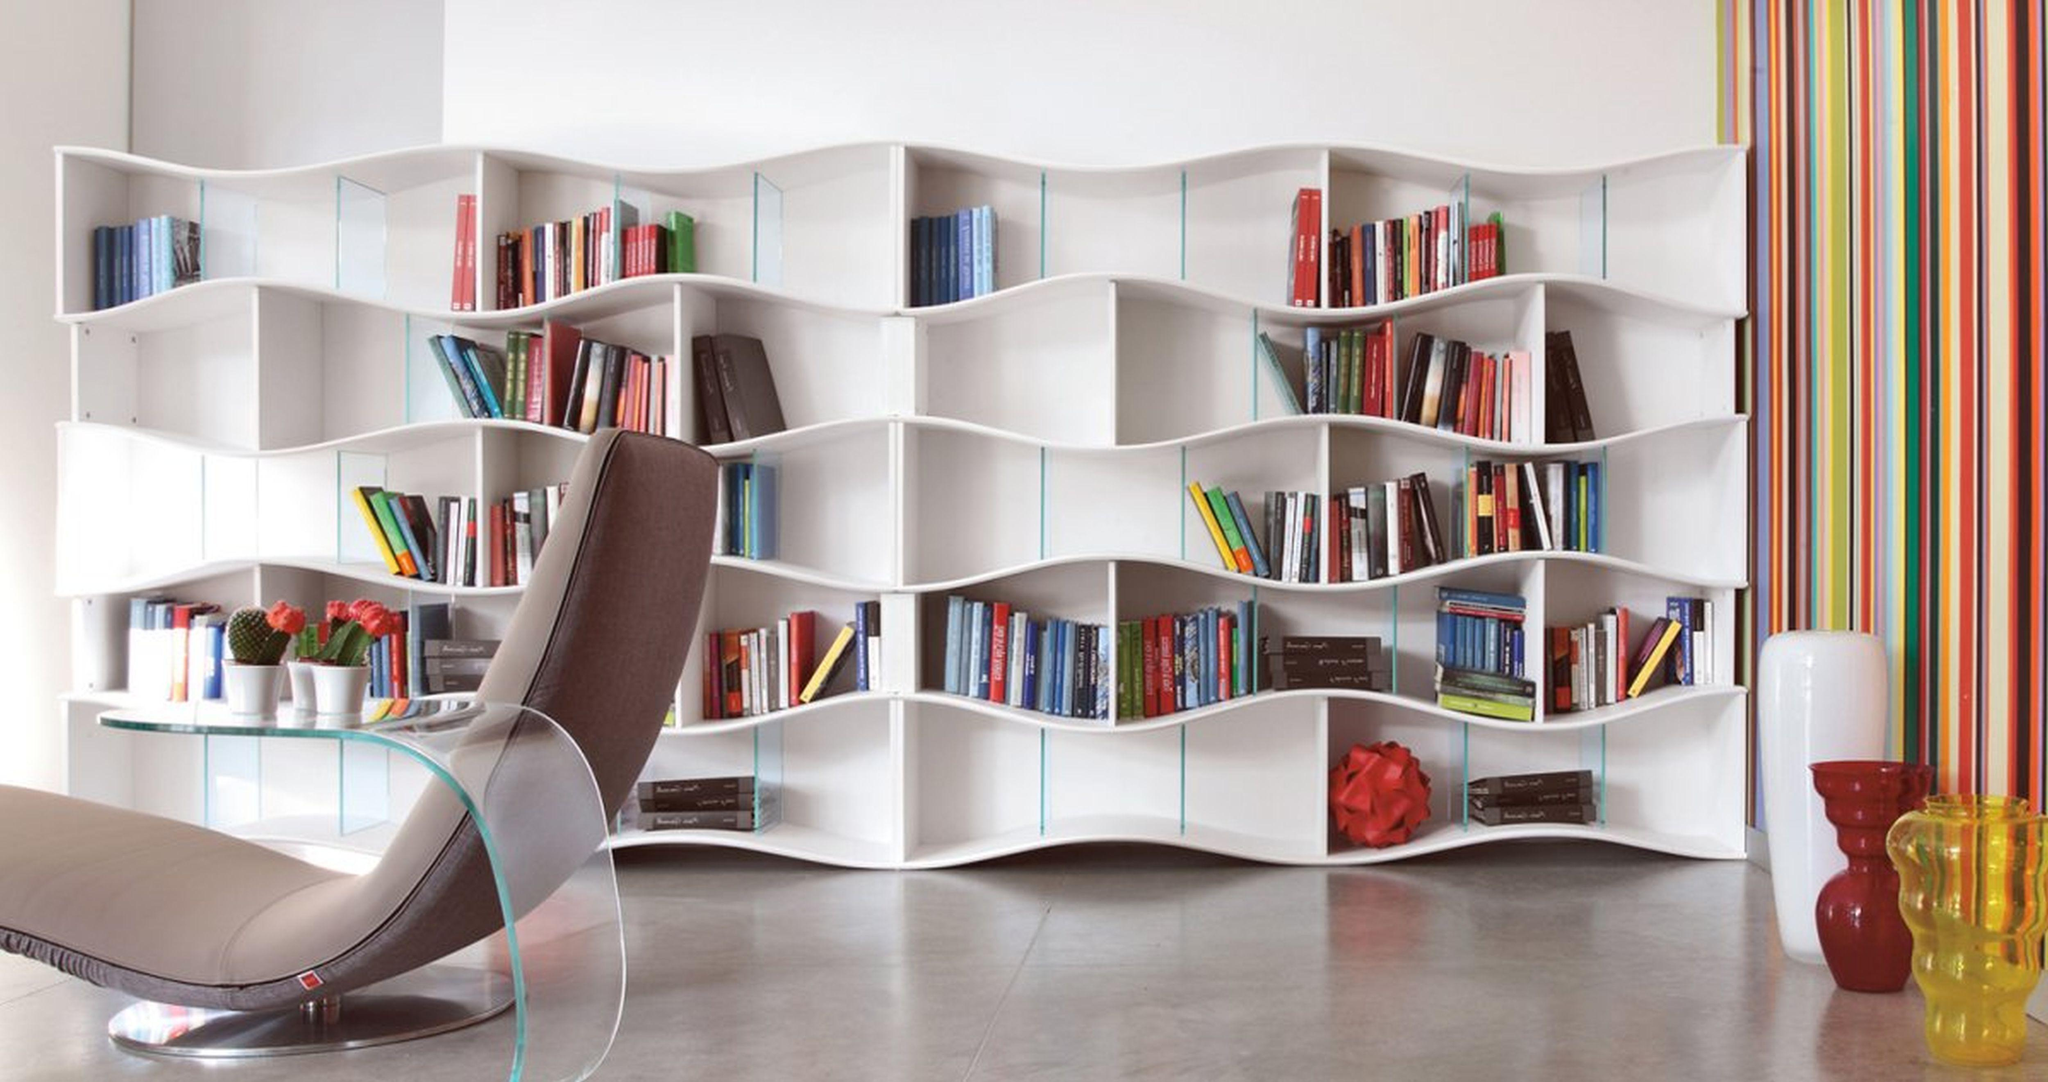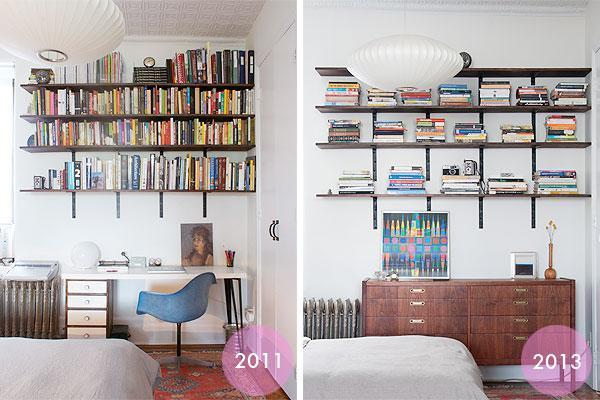The first image is the image on the left, the second image is the image on the right. Analyze the images presented: Is the assertion "There is an office chair in front of a desk that has four drawers." valid? Answer yes or no. Yes. The first image is the image on the left, the second image is the image on the right. For the images shown, is this caption "At least three pillows are in a window seat in one of the images." true? Answer yes or no. No. 